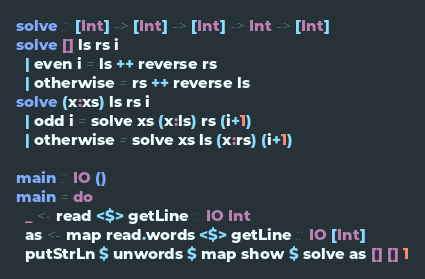Convert code to text. <code><loc_0><loc_0><loc_500><loc_500><_Haskell_>solve :: [Int] -> [Int] -> [Int] -> Int -> [Int]
solve [] ls rs i
  | even i = ls ++ reverse rs
  | otherwise = rs ++ reverse ls
solve (x:xs) ls rs i
  | odd i = solve xs (x:ls) rs (i+1)
  | otherwise = solve xs ls (x:rs) (i+1)

main :: IO ()
main = do
  _ <- read <$> getLine :: IO Int
  as <- map read.words <$> getLine :: IO [Int]
  putStrLn $ unwords $ map show $ solve as [] [] 1
</code> 